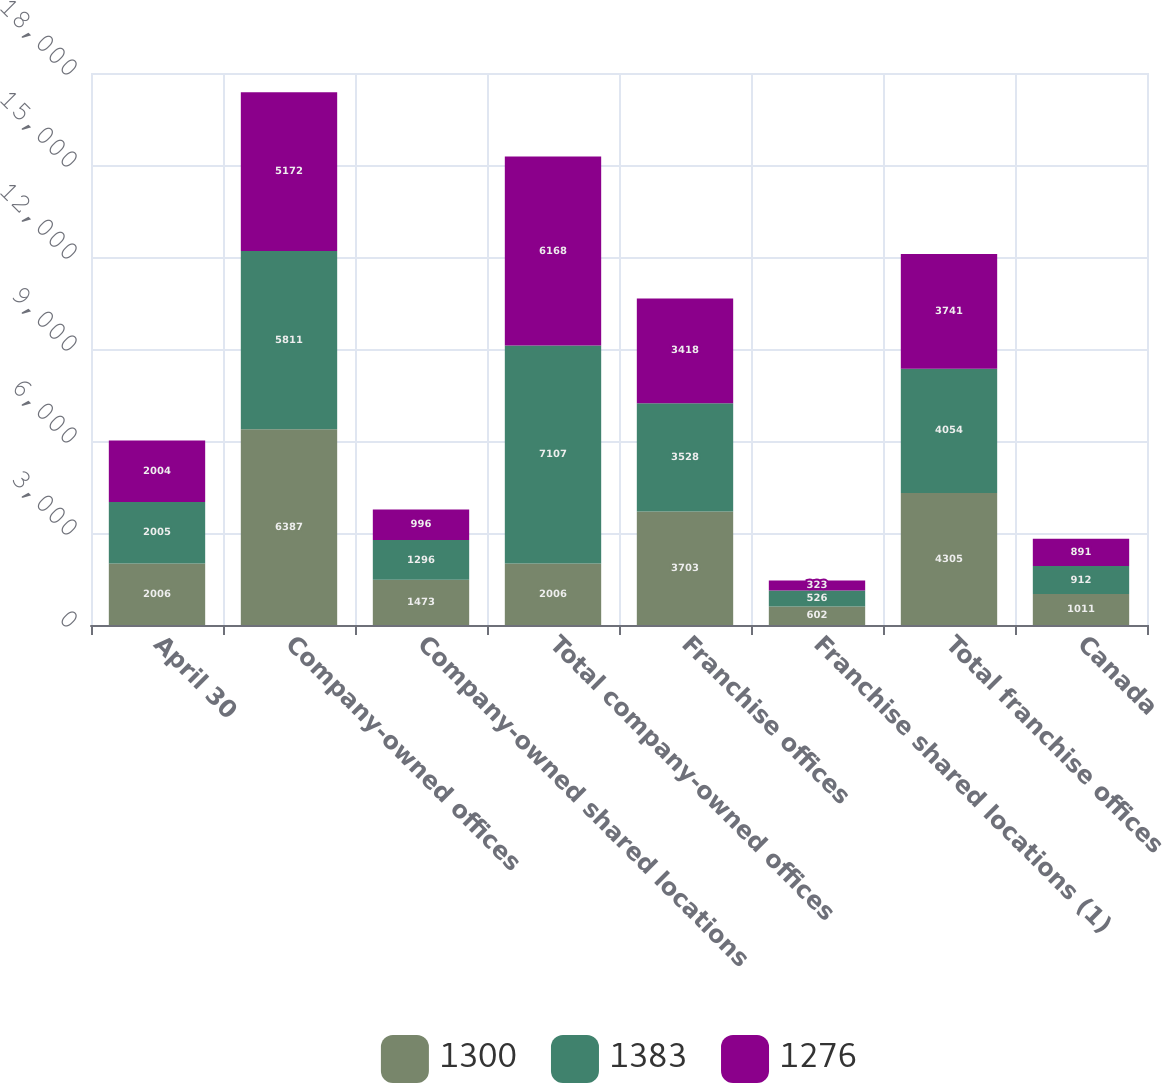Convert chart to OTSL. <chart><loc_0><loc_0><loc_500><loc_500><stacked_bar_chart><ecel><fcel>April 30<fcel>Company-owned offices<fcel>Company-owned shared locations<fcel>Total company-owned offices<fcel>Franchise offices<fcel>Franchise shared locations (1)<fcel>Total franchise offices<fcel>Canada<nl><fcel>1300<fcel>2006<fcel>6387<fcel>1473<fcel>2006<fcel>3703<fcel>602<fcel>4305<fcel>1011<nl><fcel>1383<fcel>2005<fcel>5811<fcel>1296<fcel>7107<fcel>3528<fcel>526<fcel>4054<fcel>912<nl><fcel>1276<fcel>2004<fcel>5172<fcel>996<fcel>6168<fcel>3418<fcel>323<fcel>3741<fcel>891<nl></chart> 